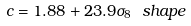<formula> <loc_0><loc_0><loc_500><loc_500>c = 1 . 8 8 + 2 3 . 9 \sigma _ { 8 } \ s h a p e</formula> 